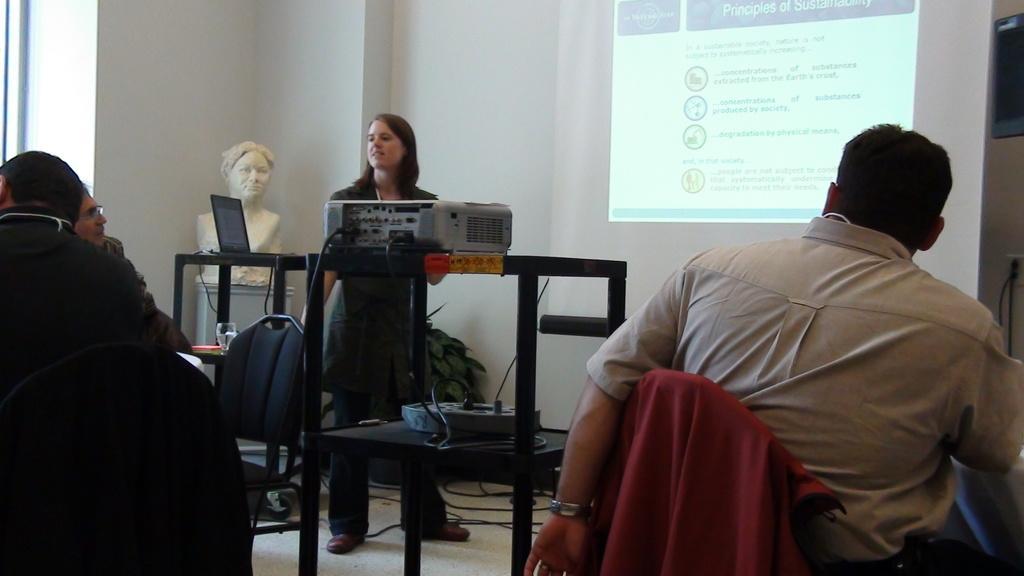How would you summarize this image in a sentence or two? In this image In the middle there is a woman she is standing her hair is short. On the right there is a man he wear shirt, trouser. On the left there are many people, chair, grass, laptop, statue and wall. 